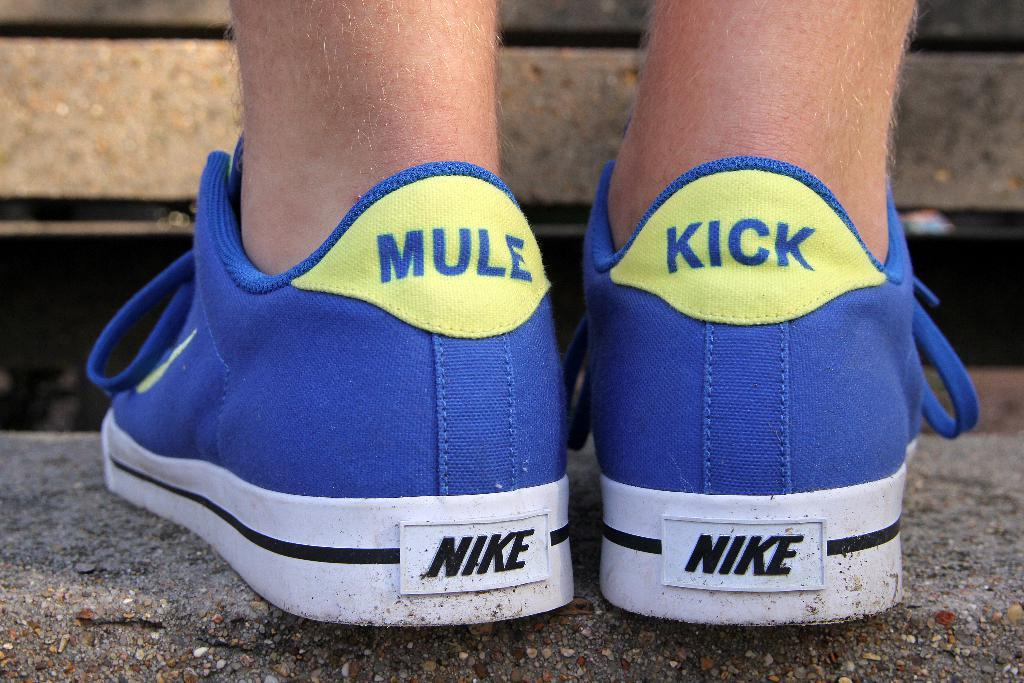<image>
Share a concise interpretation of the image provided. A pair of blue Nike shoes has the words "mule" and "kick" on the heels. 